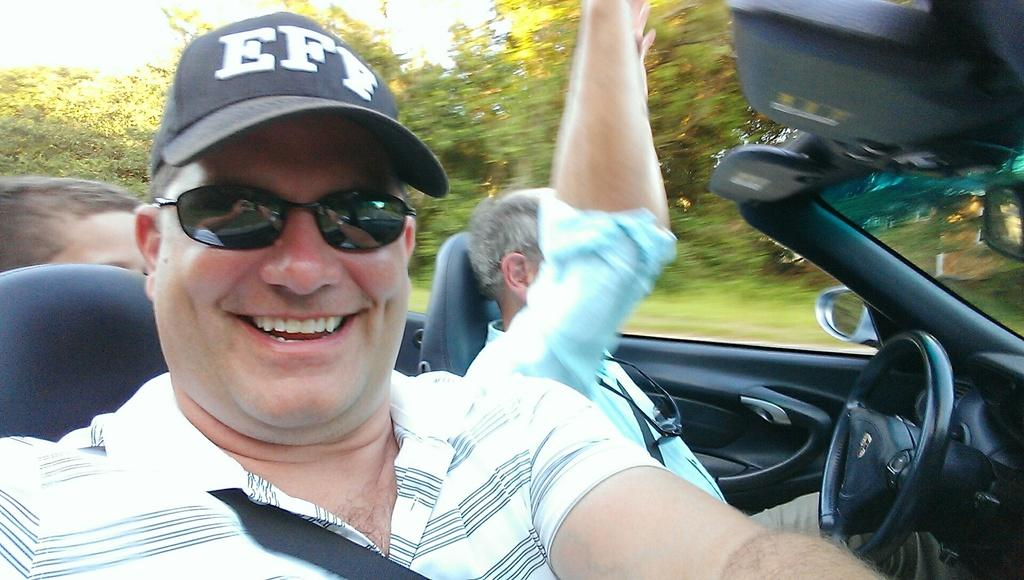What are the people in the image doing? The people in the image are sitting in a car. Can you describe the man's attire in the image? The man is wearing a cap, black color shades, and a t-shirt. What can be seen in the background of the image? There are trees in the background of the image. How many arms does the maid have in the image? There is no maid present in the image, so it is not possible to determine the number of arms she might have. 